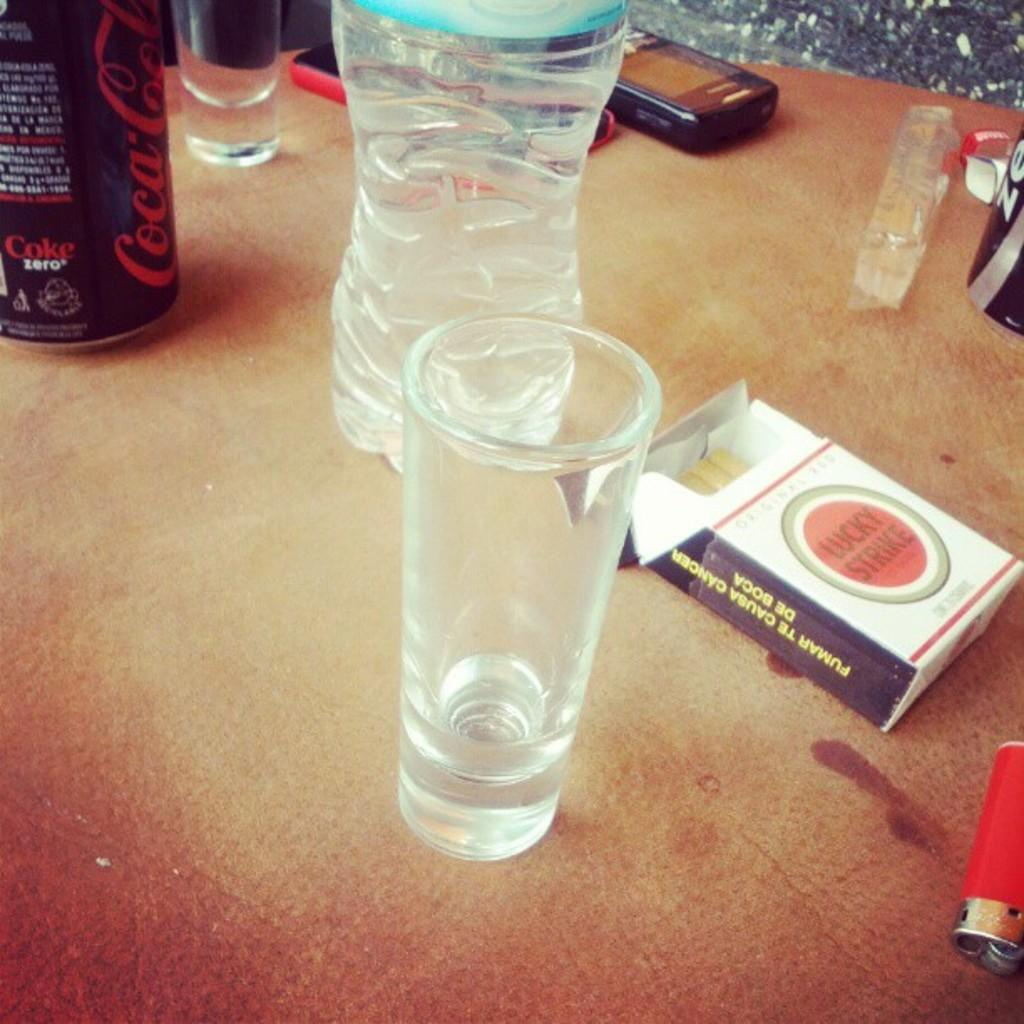<image>
Share a concise interpretation of the image provided. a pack of lucky strike cigarettes on a table 